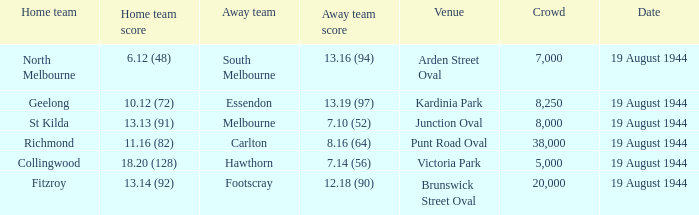What is Fitzroy's Home team Crowd? 20000.0. 